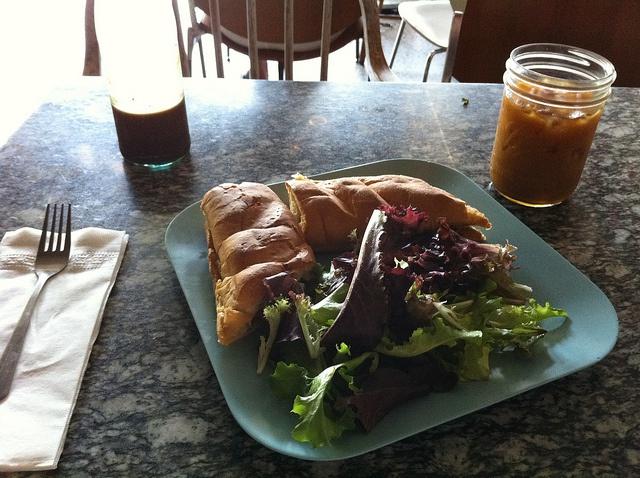Describe the objects in this image and their specific colors. I can see dining table in ivory, black, gray, white, and darkgray tones, sandwich in ivory, maroon, black, and gray tones, chair in ivory, white, maroon, gray, and black tones, cup in ivory, black, maroon, and brown tones, and bottle in ivory, black, and maroon tones in this image. 